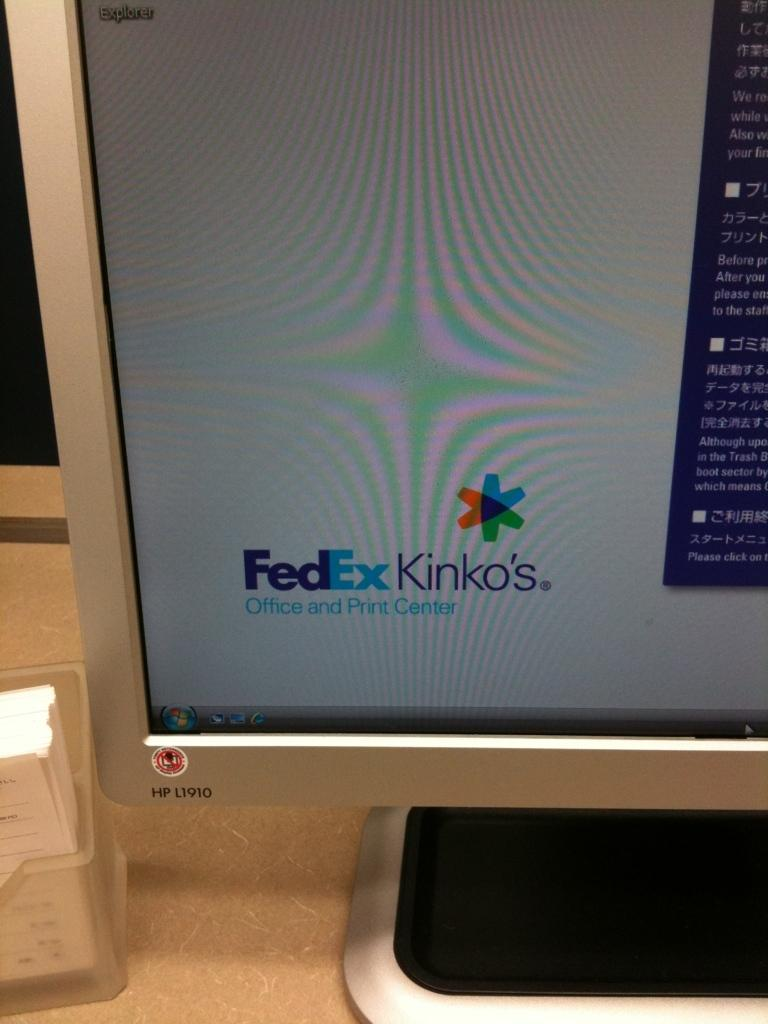<image>
Summarize the visual content of the image. A computer monitor showing a screen for FedEx Kinko's. 